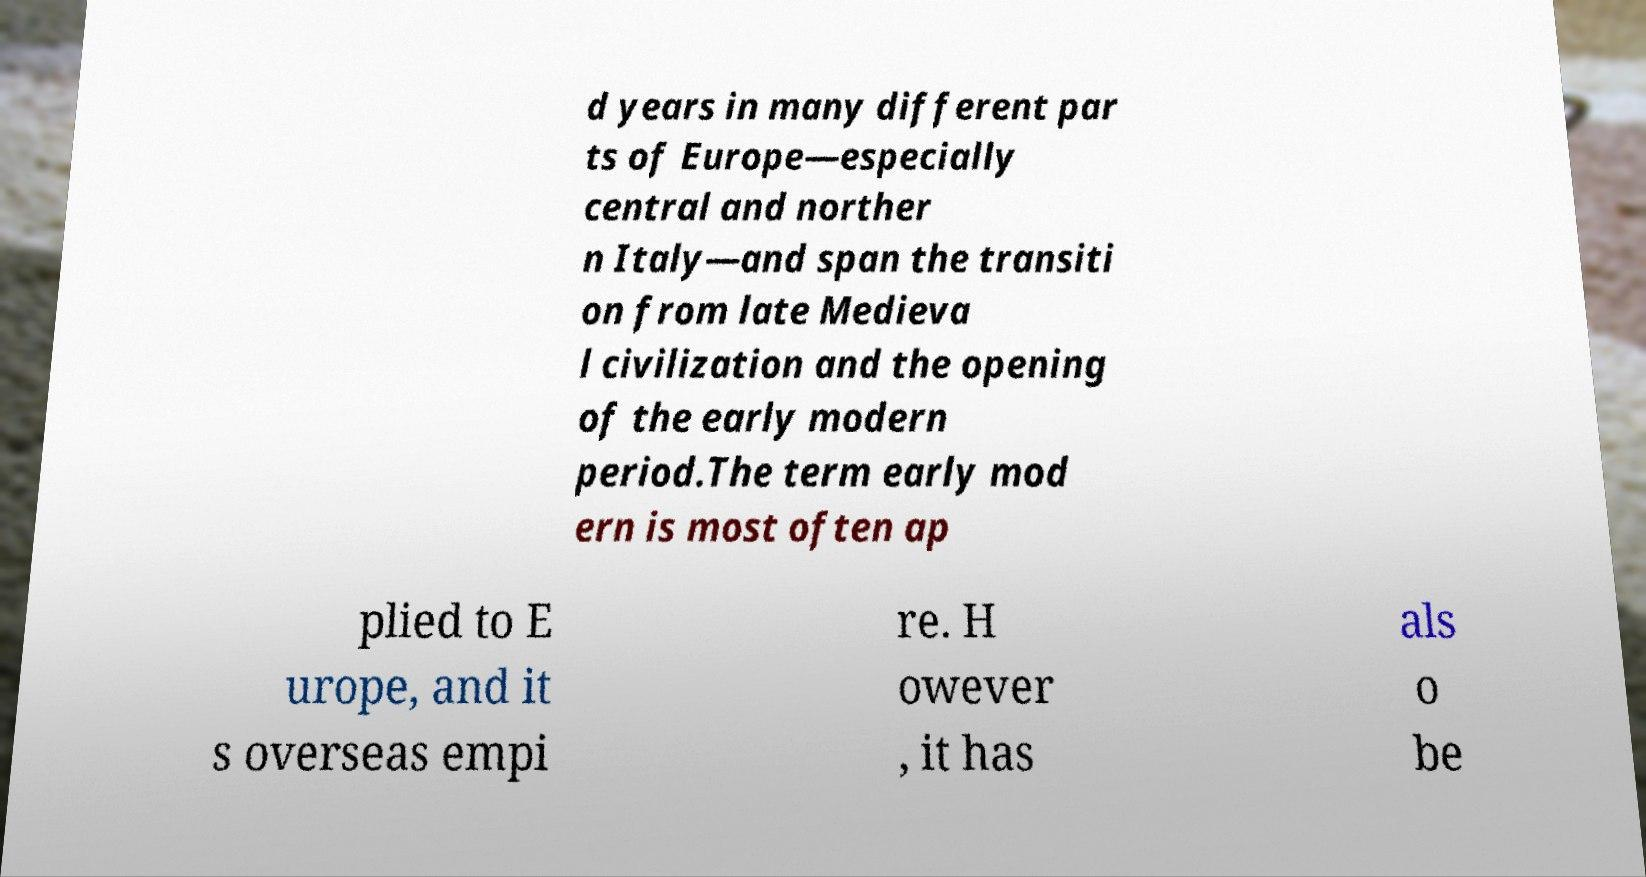Can you accurately transcribe the text from the provided image for me? d years in many different par ts of Europe—especially central and norther n Italy—and span the transiti on from late Medieva l civilization and the opening of the early modern period.The term early mod ern is most often ap plied to E urope, and it s overseas empi re. H owever , it has als o be 